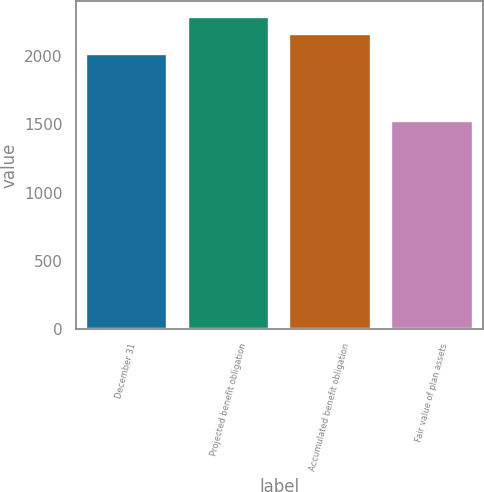Convert chart. <chart><loc_0><loc_0><loc_500><loc_500><bar_chart><fcel>December 31<fcel>Projected benefit obligation<fcel>Accumulated benefit obligation<fcel>Fair value of plan assets<nl><fcel>2017<fcel>2287<fcel>2163<fcel>1521<nl></chart> 